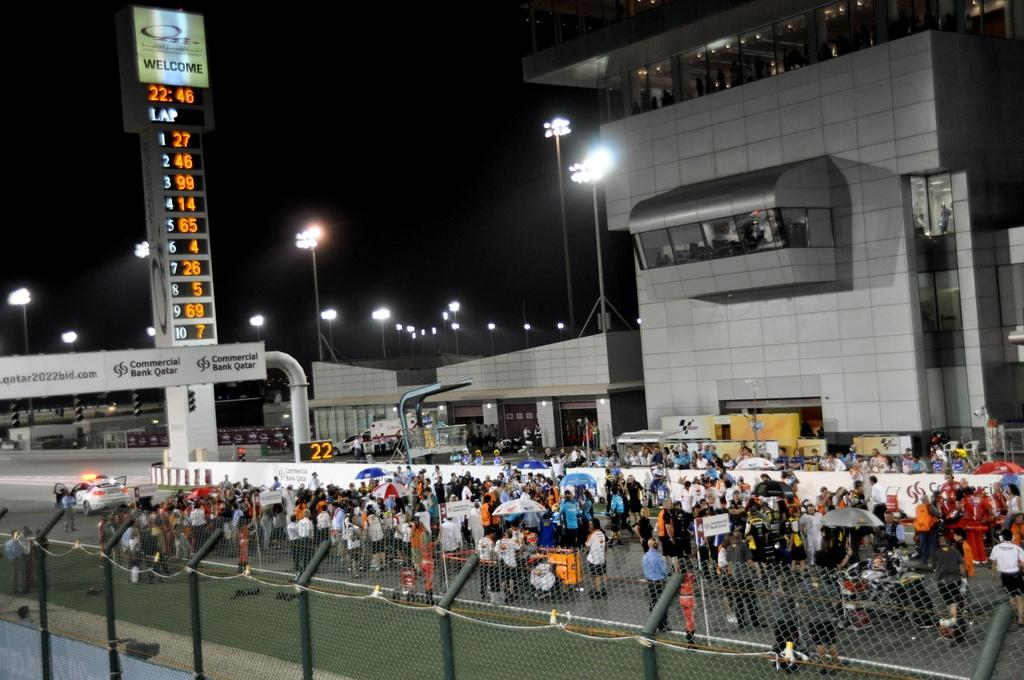What type of structure can be seen in the image? There is a fence in the image. Can you describe the people in the image? There is a group of people in the image. What is hanging or displayed in the image? There is a banner in the image. What type of man-made structures are visible in the image? There are buildings in the image. What type of lighting is present in the image? There are street lamps in the image. What part of the natural environment is visible in the image? The sky is visible in the image. Can you tell me how many brothers are depicted on the seashore in the image? There is no seashore or brothers present in the image. What type of ornament is hanging from the street lamps in the image? There is no ornament hanging from the street lamps in the image; only the street lamps themselves are visible. 